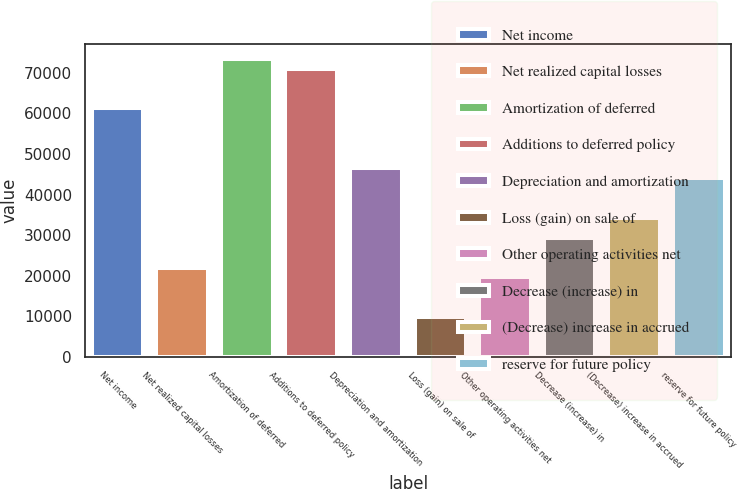<chart> <loc_0><loc_0><loc_500><loc_500><bar_chart><fcel>Net income<fcel>Net realized capital losses<fcel>Amortization of deferred<fcel>Additions to deferred policy<fcel>Depreciation and amortization<fcel>Loss (gain) on sale of<fcel>Other operating activities net<fcel>Decrease (increase) in<fcel>(Decrease) increase in accrued<fcel>reserve for future policy<nl><fcel>61212<fcel>22037.6<fcel>73454<fcel>71005.6<fcel>46521.6<fcel>9795.6<fcel>19589.2<fcel>29382.8<fcel>34279.6<fcel>44073.2<nl></chart> 